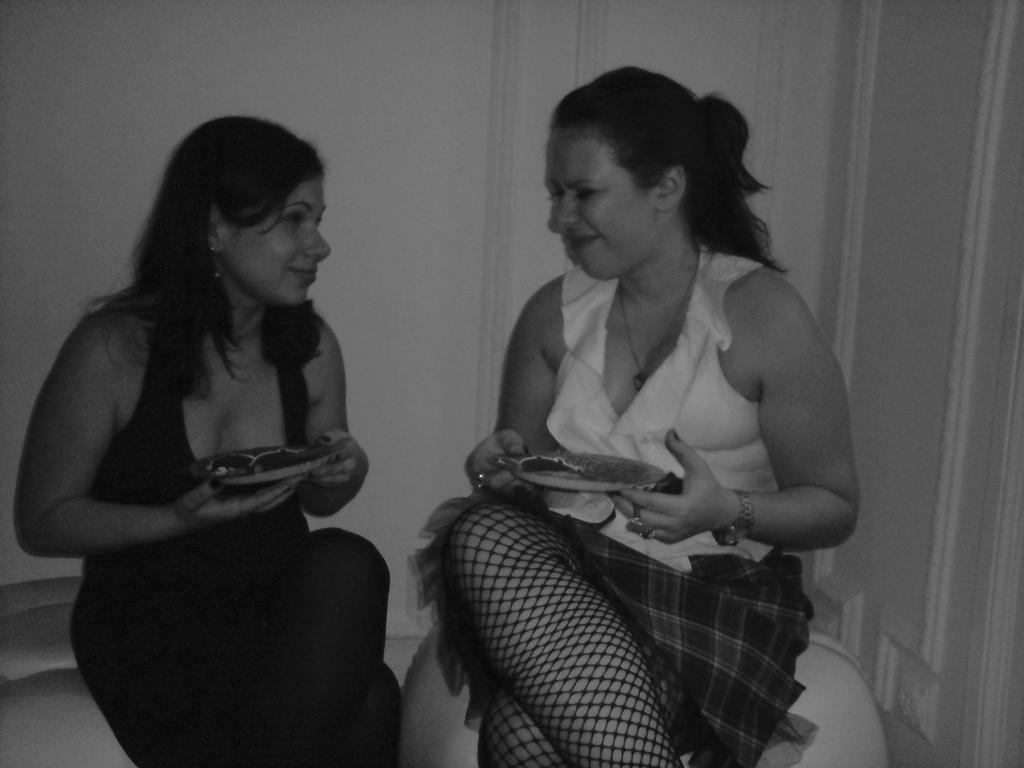Who is present in the image? There are women in the image. What are the women doing in the image? The women are sitting on chairs and holding plates in their hands. What is the color scheme of the image? The image is in black and white color. What type of transport can be seen in the image? There is no transport visible in the image; it features women sitting on chairs and holding plates. What color is the vest worn by the women in the image? There is no mention of a vest in the image, and the women are not wearing any visible clothing items besides the plates they are holding. 